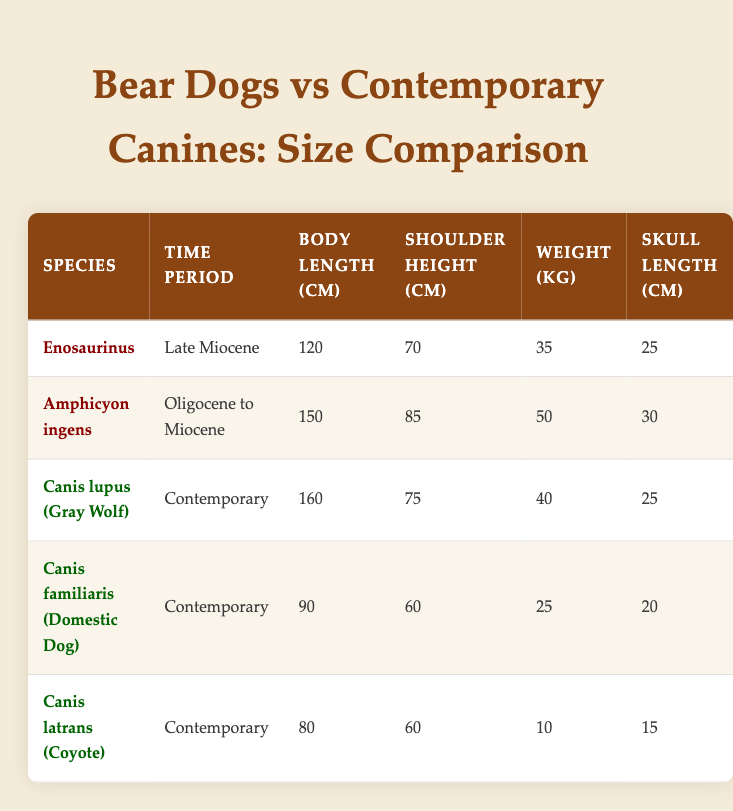What is the body length of Amphicyon ingens? The table lists Amphicyon ingens in the second row. By looking at the "Body Length (cm)" column, the value corresponding to this species is 150 cm.
Answer: 150 cm What is the weight of Canis familiaris? In the table, Canis familiaris appears and according to the "Weight (kg)" column, this domestic dog weighs 25 kg.
Answer: 25 kg Which species has the greatest shoulder height? By examining the table, we can see the shoulder heights of all species. Amphicyon ingens has the largest shoulder height of 85 cm, compared to others, making it the species with the greatest height.
Answer: Amphicyon ingens What is the difference in body length between Canis lupus and Enosaurinus? The body length for Canis lupus is 160 cm, and for Enosaurinus, it is 120 cm. The difference is calculated as 160 cm - 120 cm = 40 cm. Thus, the body length difference is 40 cm.
Answer: 40 cm Is Canis latrans heavier than Enosaurinus? Canis latrans weighs 10 kg, whereas Enosaurinus weighs 35 kg. Since 10 kg is less than 35 kg, Canis latrans is not heavier.
Answer: No What is the average skull length of all bear dog species listed? The skull lengths for bear dog species are 25 cm (Enosaurinus) and 30 cm (Amphicyon ingens). The average is calculated by adding these values: 25 cm + 30 cm = 55 cm. Since there are 2 bear dog species, we divide by 2: 55 cm / 2 = 27.5 cm.
Answer: 27.5 cm Which is the heaviest species among all listed in the table? Comparing all weights, Amphicyon ingens weighs 50 kg, the heaviest compared to the other species (Canis lupus - 40 kg, Enosaurinus - 35 kg, Canis familiaris - 25 kg, Canis latrans - 10 kg). Therefore, it's the heaviest species.
Answer: Amphicyon ingens What time periods do the bear dog species belong to? Enosaurinus is from the Late Miocene, and Amphicyon ingens spans from the Oligocene to Miocene. Both species are thus associated with prehistoric time periods.
Answer: Late Miocene and Oligocene to Miocene 